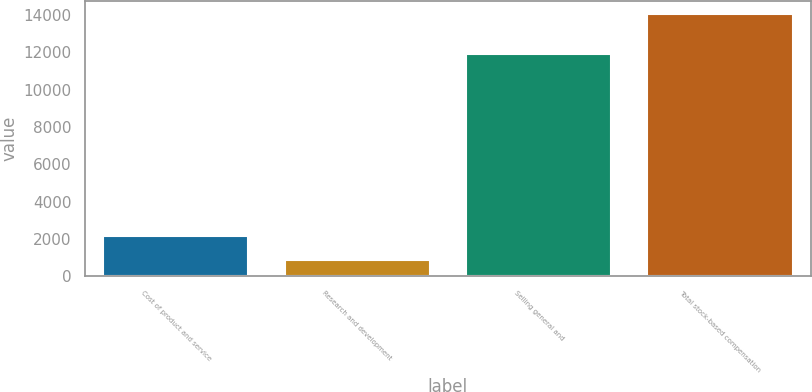Convert chart. <chart><loc_0><loc_0><loc_500><loc_500><bar_chart><fcel>Cost of product and service<fcel>Research and development<fcel>Selling general and<fcel>Total stock-based compensation<nl><fcel>2173<fcel>853<fcel>11896<fcel>14053<nl></chart> 